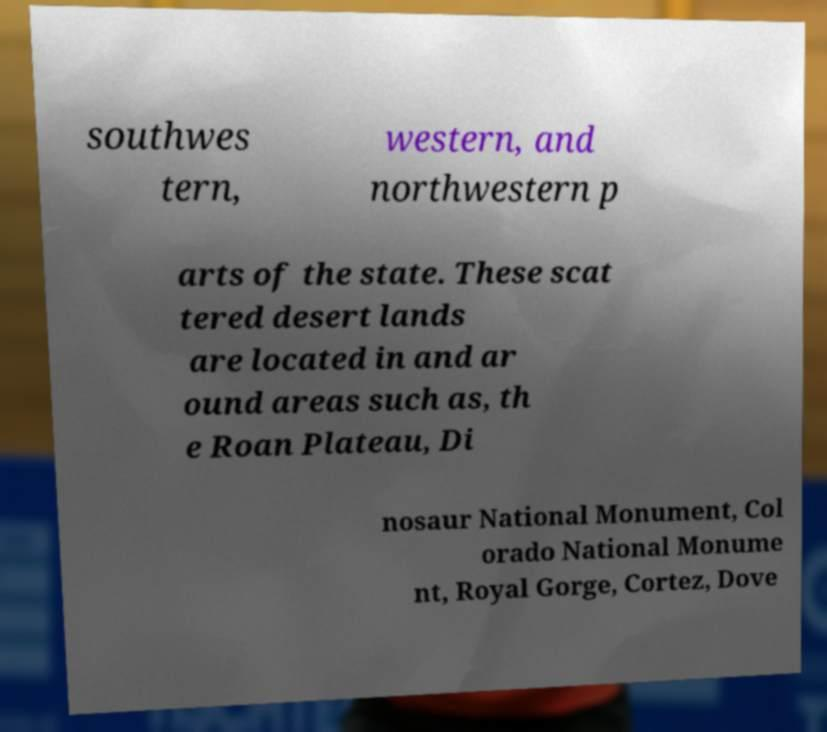Can you accurately transcribe the text from the provided image for me? southwes tern, western, and northwestern p arts of the state. These scat tered desert lands are located in and ar ound areas such as, th e Roan Plateau, Di nosaur National Monument, Col orado National Monume nt, Royal Gorge, Cortez, Dove 